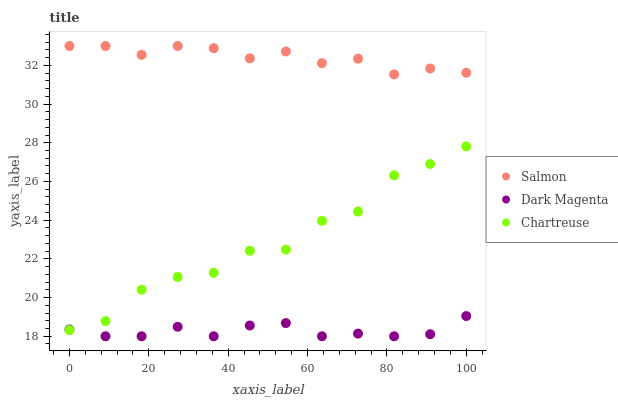Does Dark Magenta have the minimum area under the curve?
Answer yes or no. Yes. Does Salmon have the maximum area under the curve?
Answer yes or no. Yes. Does Salmon have the minimum area under the curve?
Answer yes or no. No. Does Dark Magenta have the maximum area under the curve?
Answer yes or no. No. Is Dark Magenta the smoothest?
Answer yes or no. Yes. Is Chartreuse the roughest?
Answer yes or no. Yes. Is Salmon the smoothest?
Answer yes or no. No. Is Salmon the roughest?
Answer yes or no. No. Does Dark Magenta have the lowest value?
Answer yes or no. Yes. Does Salmon have the lowest value?
Answer yes or no. No. Does Salmon have the highest value?
Answer yes or no. Yes. Does Dark Magenta have the highest value?
Answer yes or no. No. Is Dark Magenta less than Salmon?
Answer yes or no. Yes. Is Salmon greater than Chartreuse?
Answer yes or no. Yes. Does Dark Magenta intersect Chartreuse?
Answer yes or no. Yes. Is Dark Magenta less than Chartreuse?
Answer yes or no. No. Is Dark Magenta greater than Chartreuse?
Answer yes or no. No. Does Dark Magenta intersect Salmon?
Answer yes or no. No. 